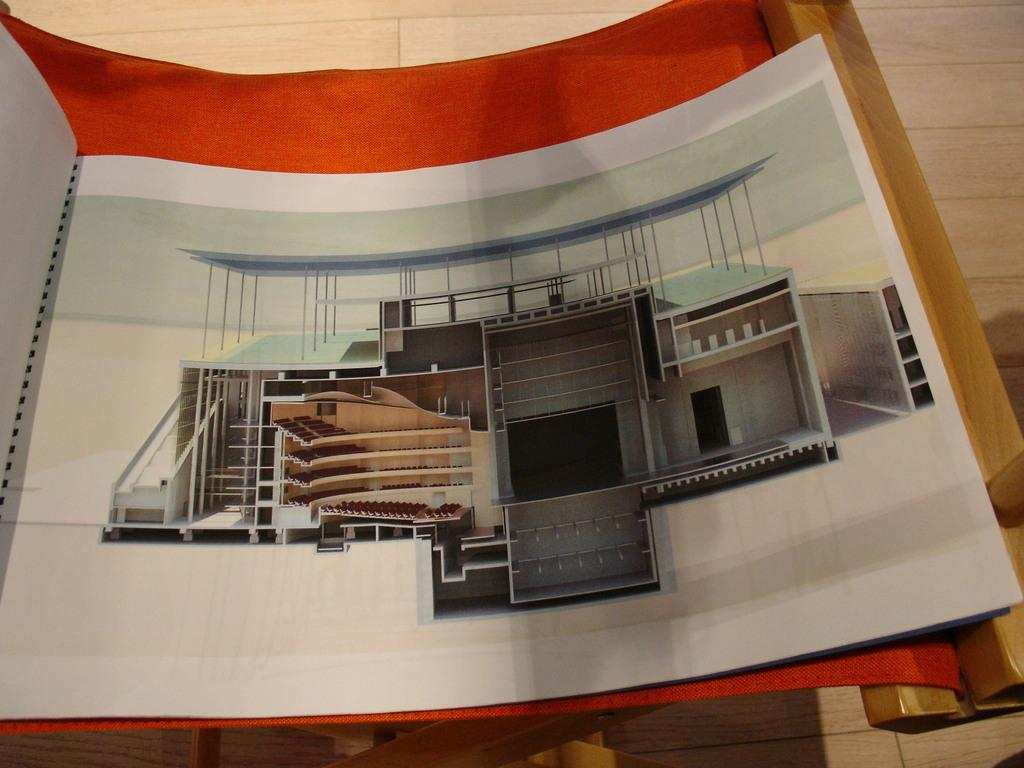What is depicted on the paper in the image? There is a picture of a building on a paper. Where is the paper located in the image? The paper is on a cloth table. What is the color of the cloth table? The cloth table has an orange color. What type of shade is provided by the building in the image? There is no shade provided by the building in the image, as it is a picture of a building on a paper and not an actual building. 